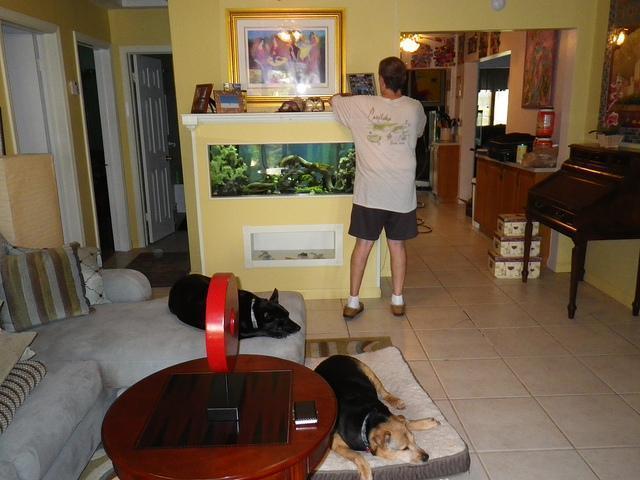How many couches are there?
Give a very brief answer. 2. How many dogs are in the photo?
Give a very brief answer. 2. 